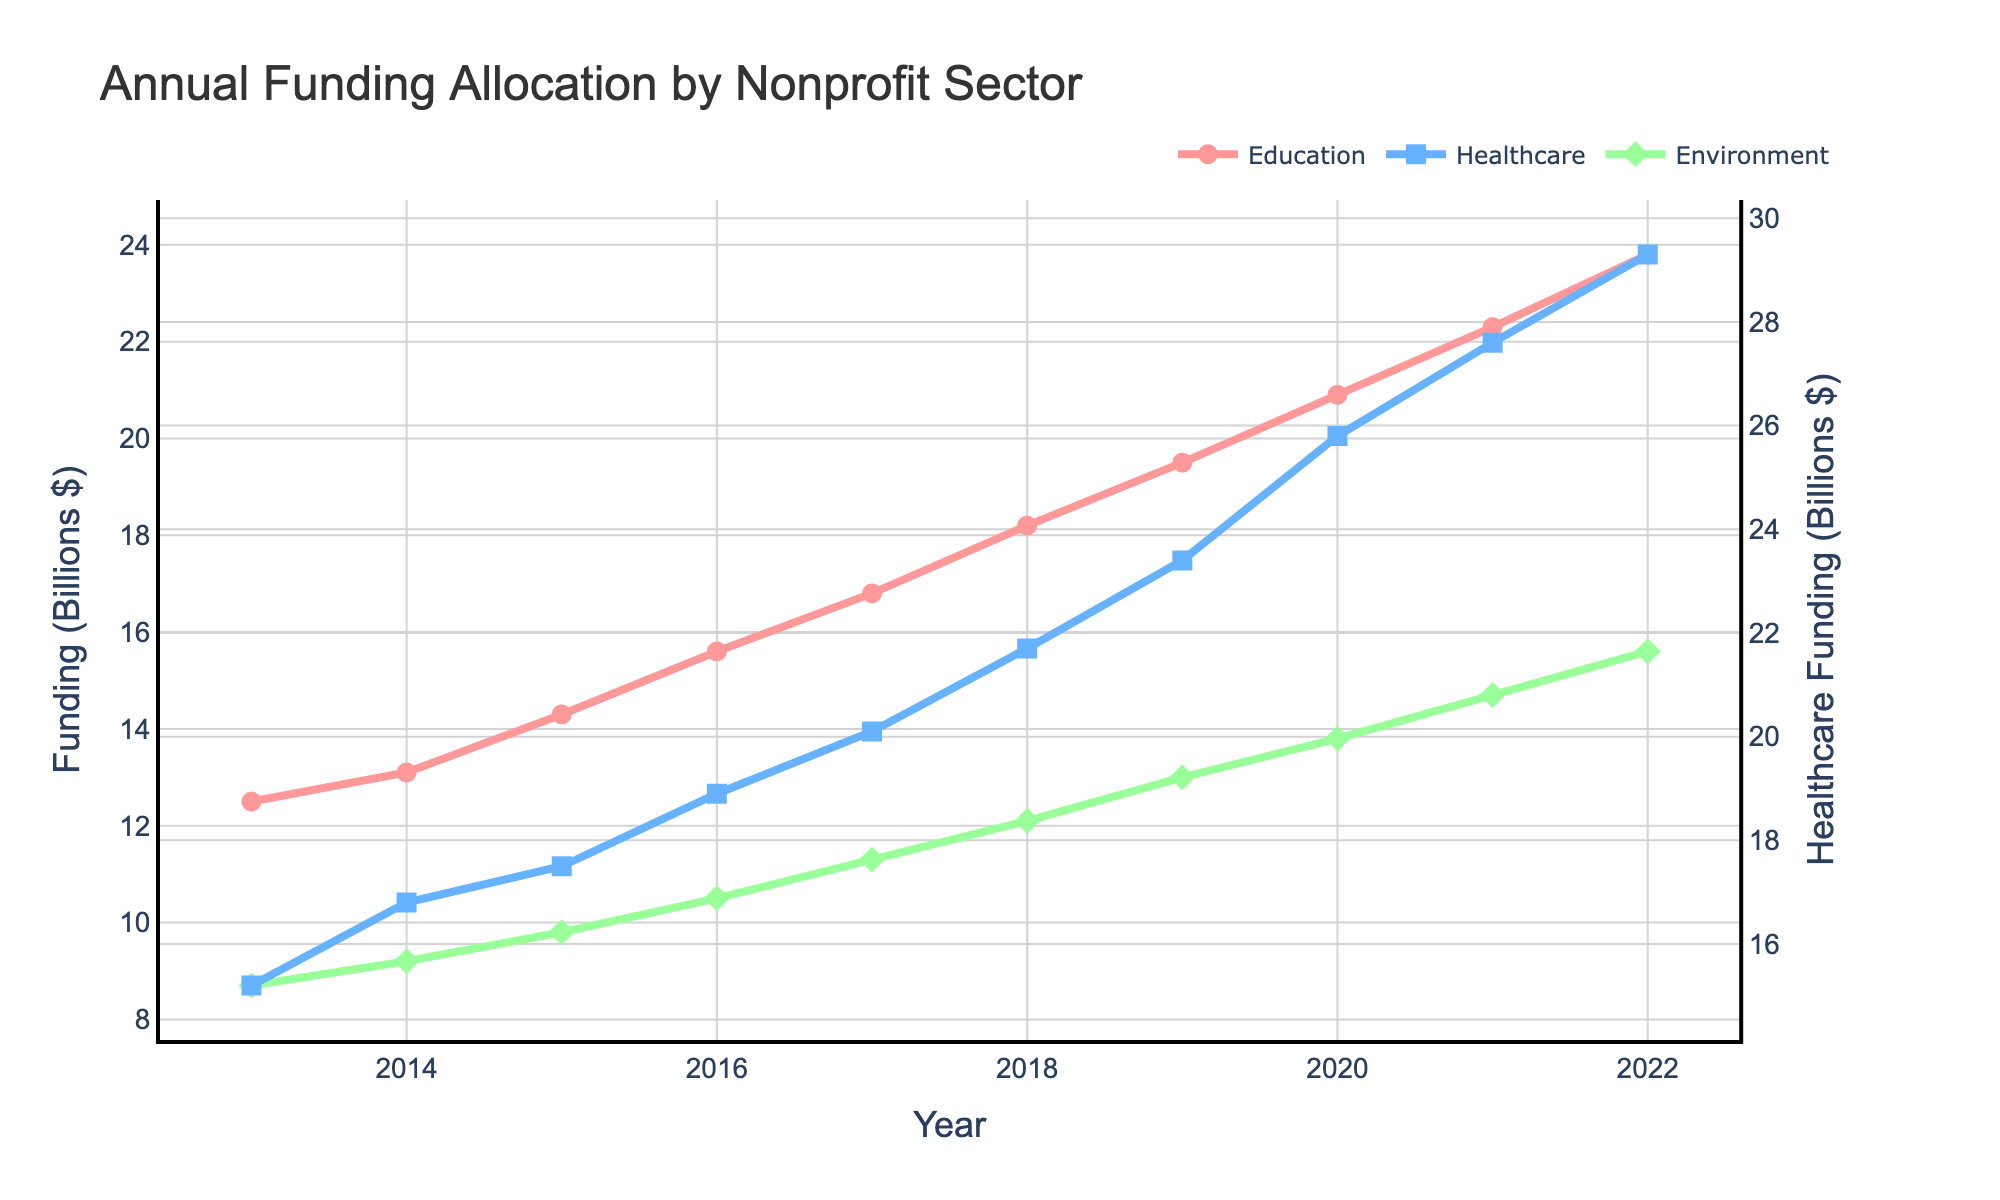What was the annual funding allocated to education and healthcare in 2014 combined? First, find the funding for education in 2014, which is 13.1 billion dollars, and for healthcare, which is 16.8 billion dollars. Then add these two numbers: 13.1 + 16.8 = 29.9
Answer: 29.9 billion dollars Which sector showed a higher increase in funding from 2017 to 2018: Environment or Education? The funding for Environment increased from 11.3 billion in 2017 to 12.1 billion in 2018, an increase of 12.1 - 11.3 = 0.8 billion dollars. For Education, it increased from 16.8 billion in 2017 to 18.2 billion in 2018, an increase of 18.2 - 16.8 = 1.4 billion dollars. Education showed a higher increase.
Answer: Education In which year did healthcare funding surpass 20 billion dollars for the first time? Locate the year where the healthcare funding exceeds 20 billion dollars for the first time. The funding surpassed 20 billion dollars in 2017 with 20.1 billion dollars.
Answer: 2017 What is the funding gap between Education and Environment in 2022? For 2022, the funding for Education is 23.8 billion dollars and for Environment, it is 15.6 billion dollars. Subtract the funding for Environment from Education: 23.8 - 15.6 = 8.2
Answer: 8.2 billion dollars How did the funding trend for Education change from 2013 to 2022? To determine the trend, observe the funding amounts for Education over the decade. Starting at 12.5 billion in 2013 and increasing each year to reach 23.8 billion in 2022. The trend indicates a continuous increase over the years.
Answer: Continuous increase Which sector had the lowest funding in 2015, and what was the amount? For 2015, compare the funding amounts for all three sectors. Education had 14.3 billion, Healthcare had 17.5 billion, and Environment had 9.8 billion. The Environment sector had the lowest funding at 9.8 billion dollars.
Answer: Environment, 9.8 billion dollars Between which consecutive years was the largest increase in funding observed for any sector? Calculate the annual differences for each sector. The largest increase was for Healthcare from 2019 to 2020, increasing from 23.4 billion to 25.8 billion: 25.8 - 23.4 = 2.4 billion.
Answer: 2019 to 2020 What's the average annual funding allocated to the Environment sector over the decade? Sum the annual funding amounts for Environment from 2013 to 2022 and divide by the number of years (10). (8.7 + 9.2 + 9.8 + 10.5 + 11.3 + 12.1 + 13.0 + 13.8 + 14.7 + 15.6) / 10 = 118.7 / 10 = 11.87
Answer: 11.87 billion dollars How does the rate of increase for Healthcare funding compare to Education funding from 2013 to 2022? Calculate the total increase for each sector over the decade. Healthcare went from 15.2 billion to 29.3 billion, an increase of 29.3 - 15.2 = 14.1 billion. Education went from 12.5 billion to 23.8 billion, an increase of 23.8 - 12.5 = 11.3 billion. The rate of increase for Healthcare funding is higher.
Answer: Healthcare has a higher increase What distinct visual markers are used to represent each sector in the plot? The plot uses different marker shapes: circles for Education, squares for Healthcare, and diamonds for Environment. Also, each sector has unique line colors: red for Education, blue for Healthcare, and green for Environment.
Answer: Circles for Education, squares for Healthcare, diamonds for Environment; red for Education, blue for Healthcare, green for Environment 